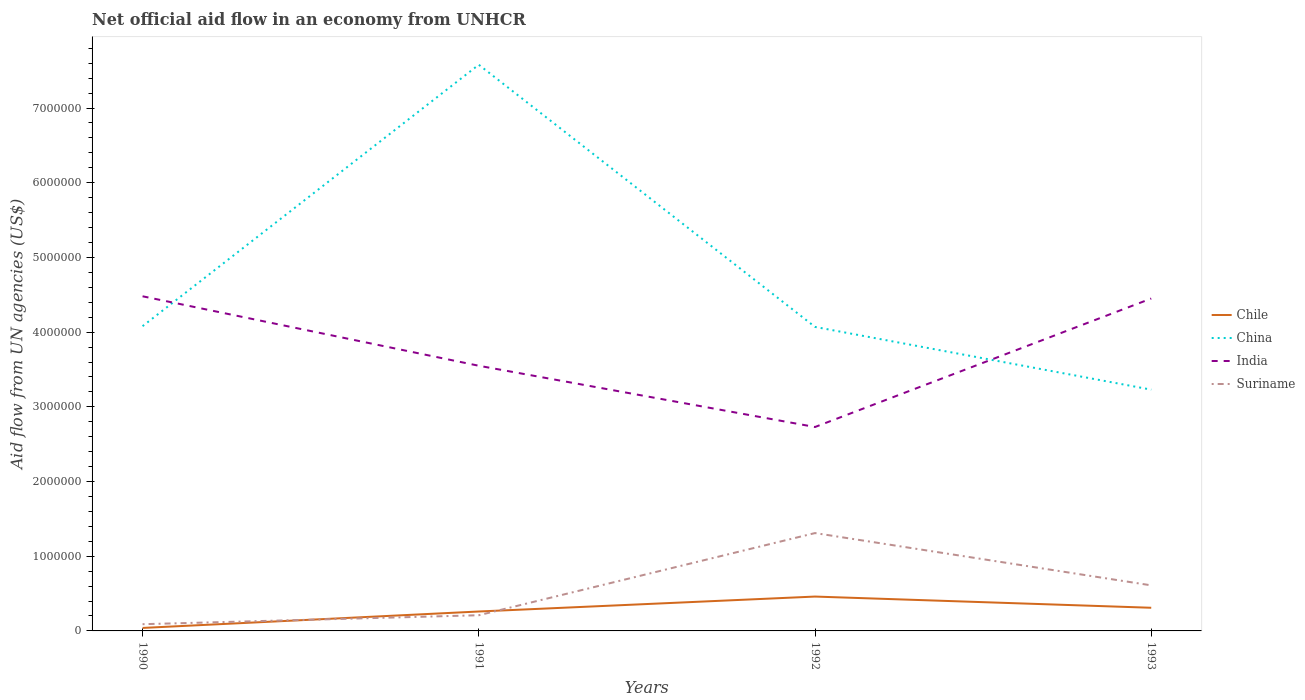Is the number of lines equal to the number of legend labels?
Ensure brevity in your answer.  Yes. Across all years, what is the maximum net official aid flow in Chile?
Offer a terse response. 4.00e+04. What is the difference between the highest and the second highest net official aid flow in Chile?
Keep it short and to the point. 4.20e+05. What is the difference between the highest and the lowest net official aid flow in Suriname?
Your response must be concise. 2. How many years are there in the graph?
Ensure brevity in your answer.  4. Where does the legend appear in the graph?
Provide a succinct answer. Center right. How many legend labels are there?
Make the answer very short. 4. How are the legend labels stacked?
Offer a very short reply. Vertical. What is the title of the graph?
Offer a terse response. Net official aid flow in an economy from UNHCR. What is the label or title of the Y-axis?
Keep it short and to the point. Aid flow from UN agencies (US$). What is the Aid flow from UN agencies (US$) of Chile in 1990?
Your response must be concise. 4.00e+04. What is the Aid flow from UN agencies (US$) of China in 1990?
Make the answer very short. 4.08e+06. What is the Aid flow from UN agencies (US$) of India in 1990?
Keep it short and to the point. 4.48e+06. What is the Aid flow from UN agencies (US$) of China in 1991?
Provide a succinct answer. 7.58e+06. What is the Aid flow from UN agencies (US$) in India in 1991?
Give a very brief answer. 3.55e+06. What is the Aid flow from UN agencies (US$) in China in 1992?
Keep it short and to the point. 4.07e+06. What is the Aid flow from UN agencies (US$) in India in 1992?
Provide a succinct answer. 2.73e+06. What is the Aid flow from UN agencies (US$) of Suriname in 1992?
Your response must be concise. 1.31e+06. What is the Aid flow from UN agencies (US$) of China in 1993?
Your response must be concise. 3.23e+06. What is the Aid flow from UN agencies (US$) of India in 1993?
Your answer should be compact. 4.45e+06. What is the Aid flow from UN agencies (US$) in Suriname in 1993?
Your answer should be compact. 6.10e+05. Across all years, what is the maximum Aid flow from UN agencies (US$) in Chile?
Your response must be concise. 4.60e+05. Across all years, what is the maximum Aid flow from UN agencies (US$) in China?
Your response must be concise. 7.58e+06. Across all years, what is the maximum Aid flow from UN agencies (US$) of India?
Your answer should be compact. 4.48e+06. Across all years, what is the maximum Aid flow from UN agencies (US$) of Suriname?
Offer a very short reply. 1.31e+06. Across all years, what is the minimum Aid flow from UN agencies (US$) of China?
Your response must be concise. 3.23e+06. Across all years, what is the minimum Aid flow from UN agencies (US$) of India?
Provide a short and direct response. 2.73e+06. Across all years, what is the minimum Aid flow from UN agencies (US$) in Suriname?
Your response must be concise. 9.00e+04. What is the total Aid flow from UN agencies (US$) of Chile in the graph?
Your answer should be very brief. 1.07e+06. What is the total Aid flow from UN agencies (US$) in China in the graph?
Ensure brevity in your answer.  1.90e+07. What is the total Aid flow from UN agencies (US$) of India in the graph?
Make the answer very short. 1.52e+07. What is the total Aid flow from UN agencies (US$) of Suriname in the graph?
Ensure brevity in your answer.  2.22e+06. What is the difference between the Aid flow from UN agencies (US$) in China in 1990 and that in 1991?
Offer a very short reply. -3.50e+06. What is the difference between the Aid flow from UN agencies (US$) in India in 1990 and that in 1991?
Your answer should be compact. 9.30e+05. What is the difference between the Aid flow from UN agencies (US$) in Chile in 1990 and that in 1992?
Offer a very short reply. -4.20e+05. What is the difference between the Aid flow from UN agencies (US$) of China in 1990 and that in 1992?
Offer a terse response. 10000. What is the difference between the Aid flow from UN agencies (US$) in India in 1990 and that in 1992?
Make the answer very short. 1.75e+06. What is the difference between the Aid flow from UN agencies (US$) of Suriname in 1990 and that in 1992?
Offer a very short reply. -1.22e+06. What is the difference between the Aid flow from UN agencies (US$) in China in 1990 and that in 1993?
Make the answer very short. 8.50e+05. What is the difference between the Aid flow from UN agencies (US$) in Suriname in 1990 and that in 1993?
Provide a succinct answer. -5.20e+05. What is the difference between the Aid flow from UN agencies (US$) in China in 1991 and that in 1992?
Provide a succinct answer. 3.51e+06. What is the difference between the Aid flow from UN agencies (US$) in India in 1991 and that in 1992?
Your answer should be compact. 8.20e+05. What is the difference between the Aid flow from UN agencies (US$) in Suriname in 1991 and that in 1992?
Make the answer very short. -1.10e+06. What is the difference between the Aid flow from UN agencies (US$) of China in 1991 and that in 1993?
Your answer should be compact. 4.35e+06. What is the difference between the Aid flow from UN agencies (US$) of India in 1991 and that in 1993?
Your answer should be very brief. -9.00e+05. What is the difference between the Aid flow from UN agencies (US$) of Suriname in 1991 and that in 1993?
Your answer should be very brief. -4.00e+05. What is the difference between the Aid flow from UN agencies (US$) in China in 1992 and that in 1993?
Your response must be concise. 8.40e+05. What is the difference between the Aid flow from UN agencies (US$) of India in 1992 and that in 1993?
Provide a succinct answer. -1.72e+06. What is the difference between the Aid flow from UN agencies (US$) of Chile in 1990 and the Aid flow from UN agencies (US$) of China in 1991?
Your answer should be compact. -7.54e+06. What is the difference between the Aid flow from UN agencies (US$) in Chile in 1990 and the Aid flow from UN agencies (US$) in India in 1991?
Keep it short and to the point. -3.51e+06. What is the difference between the Aid flow from UN agencies (US$) in Chile in 1990 and the Aid flow from UN agencies (US$) in Suriname in 1991?
Your answer should be very brief. -1.70e+05. What is the difference between the Aid flow from UN agencies (US$) of China in 1990 and the Aid flow from UN agencies (US$) of India in 1991?
Ensure brevity in your answer.  5.30e+05. What is the difference between the Aid flow from UN agencies (US$) in China in 1990 and the Aid flow from UN agencies (US$) in Suriname in 1991?
Make the answer very short. 3.87e+06. What is the difference between the Aid flow from UN agencies (US$) in India in 1990 and the Aid flow from UN agencies (US$) in Suriname in 1991?
Keep it short and to the point. 4.27e+06. What is the difference between the Aid flow from UN agencies (US$) in Chile in 1990 and the Aid flow from UN agencies (US$) in China in 1992?
Keep it short and to the point. -4.03e+06. What is the difference between the Aid flow from UN agencies (US$) of Chile in 1990 and the Aid flow from UN agencies (US$) of India in 1992?
Your answer should be very brief. -2.69e+06. What is the difference between the Aid flow from UN agencies (US$) of Chile in 1990 and the Aid flow from UN agencies (US$) of Suriname in 1992?
Your response must be concise. -1.27e+06. What is the difference between the Aid flow from UN agencies (US$) of China in 1990 and the Aid flow from UN agencies (US$) of India in 1992?
Your answer should be compact. 1.35e+06. What is the difference between the Aid flow from UN agencies (US$) in China in 1990 and the Aid flow from UN agencies (US$) in Suriname in 1992?
Provide a succinct answer. 2.77e+06. What is the difference between the Aid flow from UN agencies (US$) in India in 1990 and the Aid flow from UN agencies (US$) in Suriname in 1992?
Offer a very short reply. 3.17e+06. What is the difference between the Aid flow from UN agencies (US$) of Chile in 1990 and the Aid flow from UN agencies (US$) of China in 1993?
Make the answer very short. -3.19e+06. What is the difference between the Aid flow from UN agencies (US$) of Chile in 1990 and the Aid flow from UN agencies (US$) of India in 1993?
Offer a terse response. -4.41e+06. What is the difference between the Aid flow from UN agencies (US$) of Chile in 1990 and the Aid flow from UN agencies (US$) of Suriname in 1993?
Offer a terse response. -5.70e+05. What is the difference between the Aid flow from UN agencies (US$) of China in 1990 and the Aid flow from UN agencies (US$) of India in 1993?
Make the answer very short. -3.70e+05. What is the difference between the Aid flow from UN agencies (US$) of China in 1990 and the Aid flow from UN agencies (US$) of Suriname in 1993?
Provide a succinct answer. 3.47e+06. What is the difference between the Aid flow from UN agencies (US$) in India in 1990 and the Aid flow from UN agencies (US$) in Suriname in 1993?
Make the answer very short. 3.87e+06. What is the difference between the Aid flow from UN agencies (US$) in Chile in 1991 and the Aid flow from UN agencies (US$) in China in 1992?
Offer a very short reply. -3.81e+06. What is the difference between the Aid flow from UN agencies (US$) in Chile in 1991 and the Aid flow from UN agencies (US$) in India in 1992?
Offer a terse response. -2.47e+06. What is the difference between the Aid flow from UN agencies (US$) in Chile in 1991 and the Aid flow from UN agencies (US$) in Suriname in 1992?
Offer a terse response. -1.05e+06. What is the difference between the Aid flow from UN agencies (US$) of China in 1991 and the Aid flow from UN agencies (US$) of India in 1992?
Provide a succinct answer. 4.85e+06. What is the difference between the Aid flow from UN agencies (US$) of China in 1991 and the Aid flow from UN agencies (US$) of Suriname in 1992?
Make the answer very short. 6.27e+06. What is the difference between the Aid flow from UN agencies (US$) of India in 1991 and the Aid flow from UN agencies (US$) of Suriname in 1992?
Offer a very short reply. 2.24e+06. What is the difference between the Aid flow from UN agencies (US$) in Chile in 1991 and the Aid flow from UN agencies (US$) in China in 1993?
Keep it short and to the point. -2.97e+06. What is the difference between the Aid flow from UN agencies (US$) of Chile in 1991 and the Aid flow from UN agencies (US$) of India in 1993?
Provide a short and direct response. -4.19e+06. What is the difference between the Aid flow from UN agencies (US$) of Chile in 1991 and the Aid flow from UN agencies (US$) of Suriname in 1993?
Your response must be concise. -3.50e+05. What is the difference between the Aid flow from UN agencies (US$) in China in 1991 and the Aid flow from UN agencies (US$) in India in 1993?
Provide a short and direct response. 3.13e+06. What is the difference between the Aid flow from UN agencies (US$) in China in 1991 and the Aid flow from UN agencies (US$) in Suriname in 1993?
Ensure brevity in your answer.  6.97e+06. What is the difference between the Aid flow from UN agencies (US$) in India in 1991 and the Aid flow from UN agencies (US$) in Suriname in 1993?
Ensure brevity in your answer.  2.94e+06. What is the difference between the Aid flow from UN agencies (US$) of Chile in 1992 and the Aid flow from UN agencies (US$) of China in 1993?
Give a very brief answer. -2.77e+06. What is the difference between the Aid flow from UN agencies (US$) of Chile in 1992 and the Aid flow from UN agencies (US$) of India in 1993?
Provide a short and direct response. -3.99e+06. What is the difference between the Aid flow from UN agencies (US$) in Chile in 1992 and the Aid flow from UN agencies (US$) in Suriname in 1993?
Make the answer very short. -1.50e+05. What is the difference between the Aid flow from UN agencies (US$) of China in 1992 and the Aid flow from UN agencies (US$) of India in 1993?
Give a very brief answer. -3.80e+05. What is the difference between the Aid flow from UN agencies (US$) of China in 1992 and the Aid flow from UN agencies (US$) of Suriname in 1993?
Make the answer very short. 3.46e+06. What is the difference between the Aid flow from UN agencies (US$) of India in 1992 and the Aid flow from UN agencies (US$) of Suriname in 1993?
Make the answer very short. 2.12e+06. What is the average Aid flow from UN agencies (US$) in Chile per year?
Your response must be concise. 2.68e+05. What is the average Aid flow from UN agencies (US$) of China per year?
Provide a succinct answer. 4.74e+06. What is the average Aid flow from UN agencies (US$) of India per year?
Make the answer very short. 3.80e+06. What is the average Aid flow from UN agencies (US$) in Suriname per year?
Offer a terse response. 5.55e+05. In the year 1990, what is the difference between the Aid flow from UN agencies (US$) in Chile and Aid flow from UN agencies (US$) in China?
Keep it short and to the point. -4.04e+06. In the year 1990, what is the difference between the Aid flow from UN agencies (US$) in Chile and Aid flow from UN agencies (US$) in India?
Your answer should be compact. -4.44e+06. In the year 1990, what is the difference between the Aid flow from UN agencies (US$) in Chile and Aid flow from UN agencies (US$) in Suriname?
Your answer should be very brief. -5.00e+04. In the year 1990, what is the difference between the Aid flow from UN agencies (US$) in China and Aid flow from UN agencies (US$) in India?
Your response must be concise. -4.00e+05. In the year 1990, what is the difference between the Aid flow from UN agencies (US$) in China and Aid flow from UN agencies (US$) in Suriname?
Make the answer very short. 3.99e+06. In the year 1990, what is the difference between the Aid flow from UN agencies (US$) in India and Aid flow from UN agencies (US$) in Suriname?
Your response must be concise. 4.39e+06. In the year 1991, what is the difference between the Aid flow from UN agencies (US$) in Chile and Aid flow from UN agencies (US$) in China?
Your answer should be compact. -7.32e+06. In the year 1991, what is the difference between the Aid flow from UN agencies (US$) of Chile and Aid flow from UN agencies (US$) of India?
Your answer should be very brief. -3.29e+06. In the year 1991, what is the difference between the Aid flow from UN agencies (US$) in China and Aid flow from UN agencies (US$) in India?
Make the answer very short. 4.03e+06. In the year 1991, what is the difference between the Aid flow from UN agencies (US$) in China and Aid flow from UN agencies (US$) in Suriname?
Your response must be concise. 7.37e+06. In the year 1991, what is the difference between the Aid flow from UN agencies (US$) in India and Aid flow from UN agencies (US$) in Suriname?
Ensure brevity in your answer.  3.34e+06. In the year 1992, what is the difference between the Aid flow from UN agencies (US$) of Chile and Aid flow from UN agencies (US$) of China?
Your answer should be very brief. -3.61e+06. In the year 1992, what is the difference between the Aid flow from UN agencies (US$) of Chile and Aid flow from UN agencies (US$) of India?
Provide a short and direct response. -2.27e+06. In the year 1992, what is the difference between the Aid flow from UN agencies (US$) in Chile and Aid flow from UN agencies (US$) in Suriname?
Your response must be concise. -8.50e+05. In the year 1992, what is the difference between the Aid flow from UN agencies (US$) of China and Aid flow from UN agencies (US$) of India?
Make the answer very short. 1.34e+06. In the year 1992, what is the difference between the Aid flow from UN agencies (US$) in China and Aid flow from UN agencies (US$) in Suriname?
Your response must be concise. 2.76e+06. In the year 1992, what is the difference between the Aid flow from UN agencies (US$) of India and Aid flow from UN agencies (US$) of Suriname?
Make the answer very short. 1.42e+06. In the year 1993, what is the difference between the Aid flow from UN agencies (US$) in Chile and Aid flow from UN agencies (US$) in China?
Your answer should be compact. -2.92e+06. In the year 1993, what is the difference between the Aid flow from UN agencies (US$) of Chile and Aid flow from UN agencies (US$) of India?
Provide a succinct answer. -4.14e+06. In the year 1993, what is the difference between the Aid flow from UN agencies (US$) of China and Aid flow from UN agencies (US$) of India?
Your response must be concise. -1.22e+06. In the year 1993, what is the difference between the Aid flow from UN agencies (US$) in China and Aid flow from UN agencies (US$) in Suriname?
Your answer should be very brief. 2.62e+06. In the year 1993, what is the difference between the Aid flow from UN agencies (US$) in India and Aid flow from UN agencies (US$) in Suriname?
Offer a terse response. 3.84e+06. What is the ratio of the Aid flow from UN agencies (US$) in Chile in 1990 to that in 1991?
Your answer should be very brief. 0.15. What is the ratio of the Aid flow from UN agencies (US$) of China in 1990 to that in 1991?
Make the answer very short. 0.54. What is the ratio of the Aid flow from UN agencies (US$) in India in 1990 to that in 1991?
Keep it short and to the point. 1.26. What is the ratio of the Aid flow from UN agencies (US$) of Suriname in 1990 to that in 1991?
Your answer should be very brief. 0.43. What is the ratio of the Aid flow from UN agencies (US$) of Chile in 1990 to that in 1992?
Keep it short and to the point. 0.09. What is the ratio of the Aid flow from UN agencies (US$) in India in 1990 to that in 1992?
Give a very brief answer. 1.64. What is the ratio of the Aid flow from UN agencies (US$) of Suriname in 1990 to that in 1992?
Your answer should be compact. 0.07. What is the ratio of the Aid flow from UN agencies (US$) in Chile in 1990 to that in 1993?
Keep it short and to the point. 0.13. What is the ratio of the Aid flow from UN agencies (US$) in China in 1990 to that in 1993?
Ensure brevity in your answer.  1.26. What is the ratio of the Aid flow from UN agencies (US$) of India in 1990 to that in 1993?
Ensure brevity in your answer.  1.01. What is the ratio of the Aid flow from UN agencies (US$) of Suriname in 1990 to that in 1993?
Make the answer very short. 0.15. What is the ratio of the Aid flow from UN agencies (US$) in Chile in 1991 to that in 1992?
Your response must be concise. 0.57. What is the ratio of the Aid flow from UN agencies (US$) of China in 1991 to that in 1992?
Provide a succinct answer. 1.86. What is the ratio of the Aid flow from UN agencies (US$) of India in 1991 to that in 1992?
Keep it short and to the point. 1.3. What is the ratio of the Aid flow from UN agencies (US$) in Suriname in 1991 to that in 1992?
Give a very brief answer. 0.16. What is the ratio of the Aid flow from UN agencies (US$) in Chile in 1991 to that in 1993?
Offer a very short reply. 0.84. What is the ratio of the Aid flow from UN agencies (US$) in China in 1991 to that in 1993?
Offer a terse response. 2.35. What is the ratio of the Aid flow from UN agencies (US$) in India in 1991 to that in 1993?
Your answer should be compact. 0.8. What is the ratio of the Aid flow from UN agencies (US$) of Suriname in 1991 to that in 1993?
Your response must be concise. 0.34. What is the ratio of the Aid flow from UN agencies (US$) in Chile in 1992 to that in 1993?
Make the answer very short. 1.48. What is the ratio of the Aid flow from UN agencies (US$) in China in 1992 to that in 1993?
Your answer should be very brief. 1.26. What is the ratio of the Aid flow from UN agencies (US$) in India in 1992 to that in 1993?
Offer a very short reply. 0.61. What is the ratio of the Aid flow from UN agencies (US$) in Suriname in 1992 to that in 1993?
Offer a terse response. 2.15. What is the difference between the highest and the second highest Aid flow from UN agencies (US$) in Chile?
Give a very brief answer. 1.50e+05. What is the difference between the highest and the second highest Aid flow from UN agencies (US$) of China?
Ensure brevity in your answer.  3.50e+06. What is the difference between the highest and the second highest Aid flow from UN agencies (US$) of Suriname?
Your response must be concise. 7.00e+05. What is the difference between the highest and the lowest Aid flow from UN agencies (US$) in China?
Offer a very short reply. 4.35e+06. What is the difference between the highest and the lowest Aid flow from UN agencies (US$) in India?
Your answer should be very brief. 1.75e+06. What is the difference between the highest and the lowest Aid flow from UN agencies (US$) in Suriname?
Your response must be concise. 1.22e+06. 